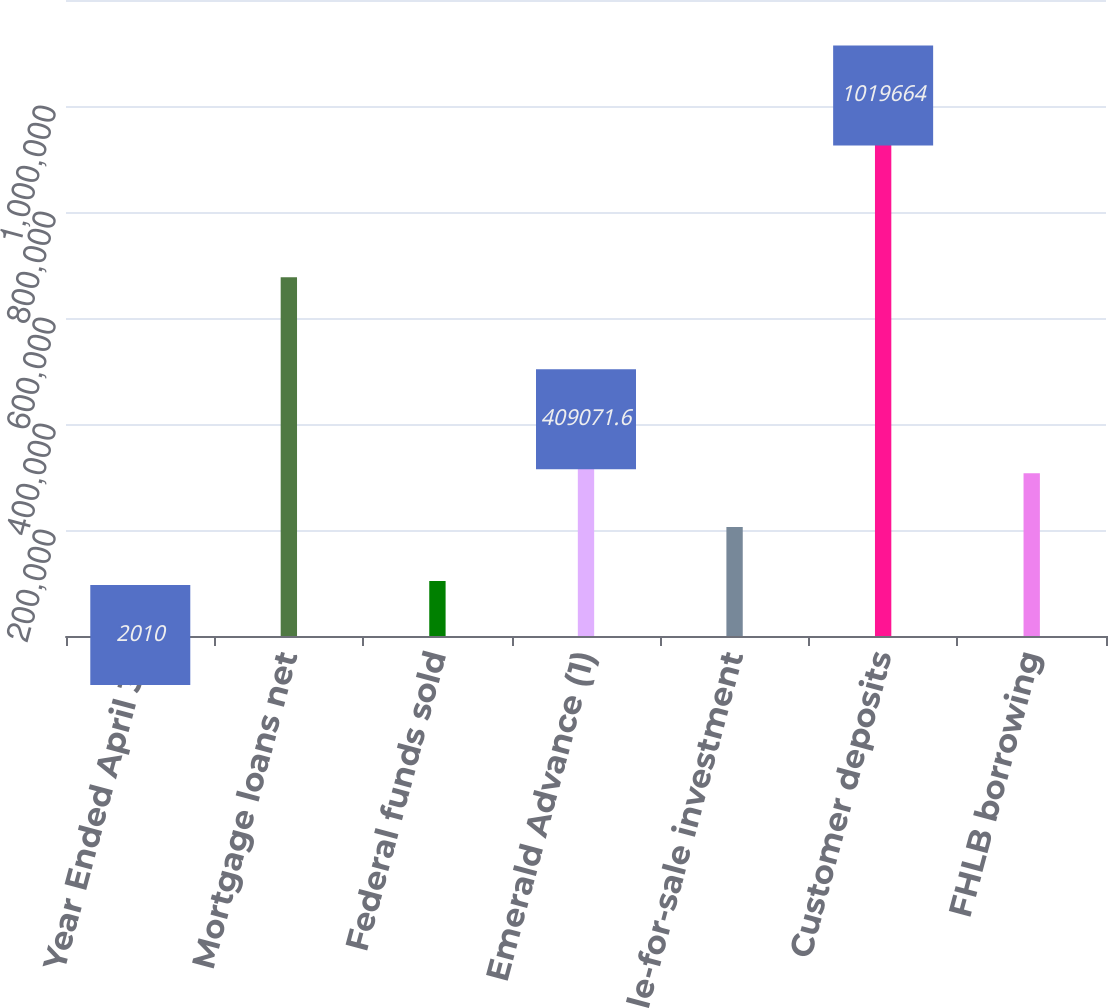Convert chart. <chart><loc_0><loc_0><loc_500><loc_500><bar_chart><fcel>Year Ended April 30<fcel>Mortgage loans net<fcel>Federal funds sold<fcel>Emerald Advance (1)<fcel>Available-for-sale investment<fcel>Customer deposits<fcel>FHLB borrowing<nl><fcel>2010<fcel>677115<fcel>103775<fcel>409072<fcel>205541<fcel>1.01966e+06<fcel>307306<nl></chart> 